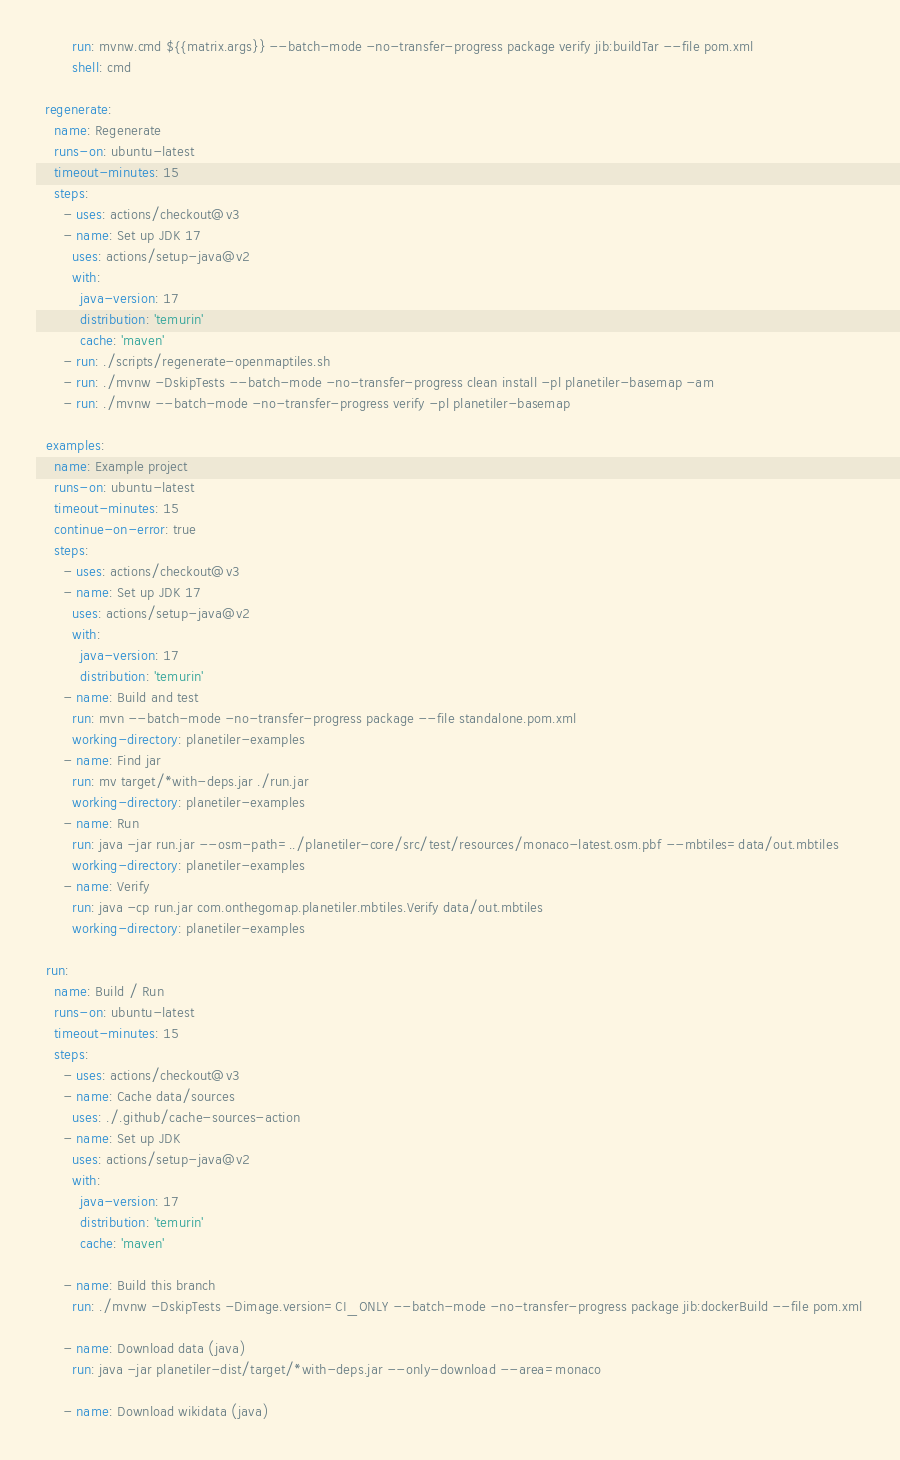<code> <loc_0><loc_0><loc_500><loc_500><_YAML_>        run: mvnw.cmd ${{matrix.args}} --batch-mode -no-transfer-progress package verify jib:buildTar --file pom.xml
        shell: cmd

  regenerate:
    name: Regenerate
    runs-on: ubuntu-latest
    timeout-minutes: 15
    steps:
      - uses: actions/checkout@v3
      - name: Set up JDK 17
        uses: actions/setup-java@v2
        with:
          java-version: 17
          distribution: 'temurin'
          cache: 'maven'
      - run: ./scripts/regenerate-openmaptiles.sh
      - run: ./mvnw -DskipTests --batch-mode -no-transfer-progress clean install -pl planetiler-basemap -am
      - run: ./mvnw --batch-mode -no-transfer-progress verify -pl planetiler-basemap

  examples:
    name: Example project
    runs-on: ubuntu-latest
    timeout-minutes: 15
    continue-on-error: true
    steps:
      - uses: actions/checkout@v3
      - name: Set up JDK 17
        uses: actions/setup-java@v2
        with:
          java-version: 17
          distribution: 'temurin'
      - name: Build and test
        run: mvn --batch-mode -no-transfer-progress package --file standalone.pom.xml
        working-directory: planetiler-examples
      - name: Find jar
        run: mv target/*with-deps.jar ./run.jar
        working-directory: planetiler-examples
      - name: Run
        run: java -jar run.jar --osm-path=../planetiler-core/src/test/resources/monaco-latest.osm.pbf --mbtiles=data/out.mbtiles
        working-directory: planetiler-examples
      - name: Verify
        run: java -cp run.jar com.onthegomap.planetiler.mbtiles.Verify data/out.mbtiles
        working-directory: planetiler-examples

  run:
    name: Build / Run
    runs-on: ubuntu-latest
    timeout-minutes: 15
    steps:
      - uses: actions/checkout@v3
      - name: Cache data/sources
        uses: ./.github/cache-sources-action
      - name: Set up JDK
        uses: actions/setup-java@v2
        with:
          java-version: 17
          distribution: 'temurin'
          cache: 'maven'

      - name: Build this branch
        run: ./mvnw -DskipTests -Dimage.version=CI_ONLY --batch-mode -no-transfer-progress package jib:dockerBuild --file pom.xml

      - name: Download data (java)
        run: java -jar planetiler-dist/target/*with-deps.jar --only-download --area=monaco

      - name: Download wikidata (java)</code> 